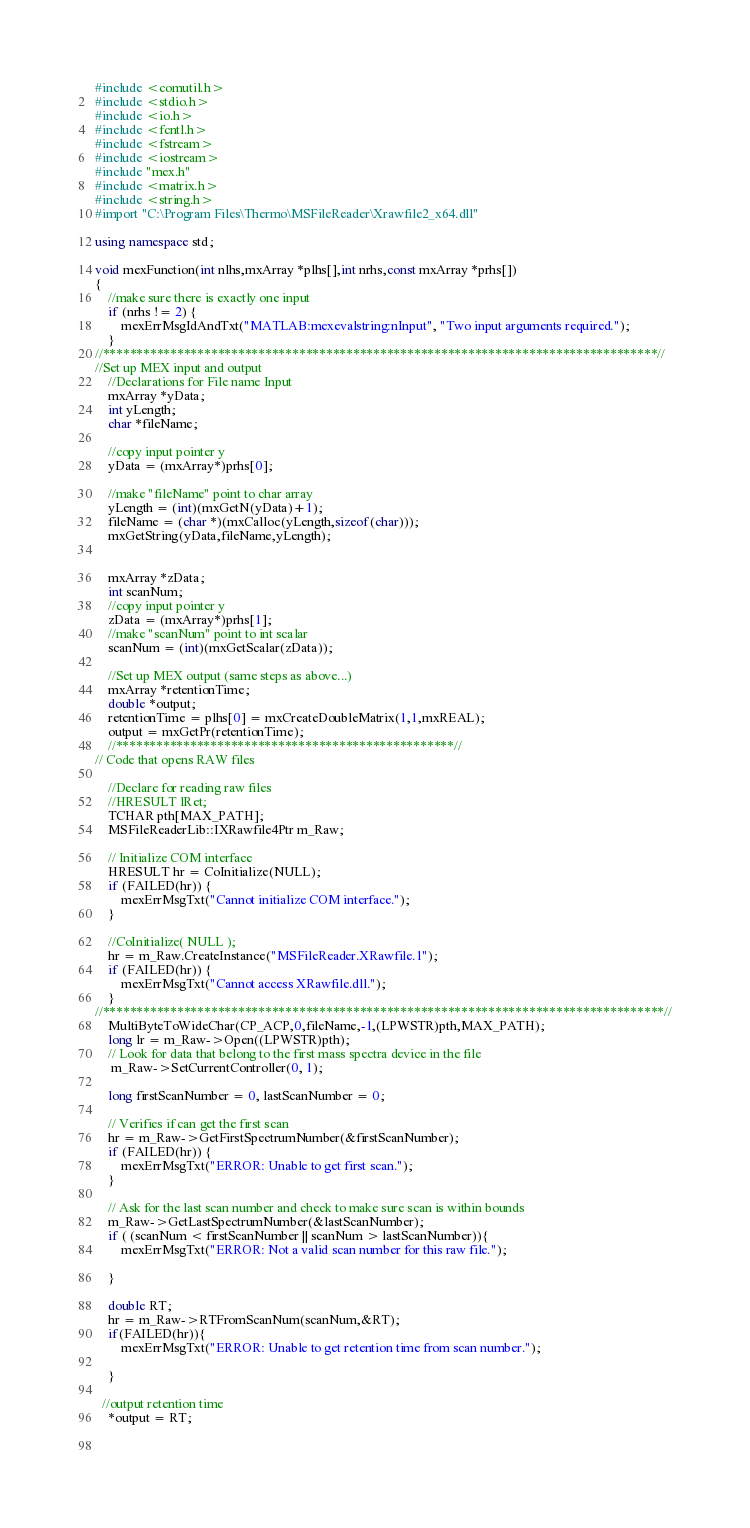<code> <loc_0><loc_0><loc_500><loc_500><_C++_>#include <comutil.h>
#include <stdio.h>
#include <io.h>
#include <fcntl.h>
#include <fstream>
#include <iostream>
#include "mex.h"
#include <matrix.h> 
#include <string.h>
#import "C:\Program Files\Thermo\MSFileReader\Xrawfile2_x64.dll"

using namespace std;

void mexFunction(int nlhs,mxArray *plhs[],int nrhs,const mxArray *prhs[])
{
    //make sure there is exactly one input
    if (nrhs != 2) {
        mexErrMsgIdAndTxt("MATLAB:mexevalstring:nInput", "Two input arguments required.");
    } 
//**********************************************************************************//
//Set up MEX input and output
    //Declarations for File name Input
    mxArray *yData;
    int yLength;
    char *fileName;
    
    //copy input pointer y
    yData = (mxArray*)prhs[0];
    
    //make "fileName" point to char array
    yLength = (int)(mxGetN(yData)+1);
    fileName = (char *)(mxCalloc(yLength,sizeof(char)));
    mxGetString(yData,fileName,yLength);

    
    mxArray *zData;
    int scanNum;
    //copy input pointer y
    zData = (mxArray*)prhs[1];
    //make "scanNum" point to int scalar
    scanNum = (int)(mxGetScalar(zData));
    
    //Set up MEX output (same steps as above...)
    mxArray *retentionTime;
    double *output;
    retentionTime = plhs[0] = mxCreateDoubleMatrix(1,1,mxREAL);
    output = mxGetPr(retentionTime);
    //**************************************************//    
// Code that opens RAW files    
    
    //Declare for reading raw files
    //HRESULT lRet;
    TCHAR pth[MAX_PATH];
    MSFileReaderLib::IXRawfile4Ptr m_Raw;
    
    // Initialize COM interface
    HRESULT hr = CoInitialize(NULL);    
    if (FAILED(hr)) {
        mexErrMsgTxt("Cannot initialize COM interface.");
    }
 
    //CoInitialize( NULL );
    hr = m_Raw.CreateInstance("MSFileReader.XRawfile.1");
    if (FAILED(hr)) {
        mexErrMsgTxt("Cannot access XRawfile.dll.");
    }
//***********************************************************************************//
    MultiByteToWideChar(CP_ACP,0,fileName,-1,(LPWSTR)pth,MAX_PATH);
    long lr = m_Raw->Open((LPWSTR)pth);
    // Look for data that belong to the first mass spectra device in the file
     m_Raw->SetCurrentController(0, 1);
    
    long firstScanNumber = 0, lastScanNumber = 0;

    // Verifies if can get the first scan
    hr = m_Raw->GetFirstSpectrumNumber(&firstScanNumber);
    if (FAILED(hr)) {
        mexErrMsgTxt("ERROR: Unable to get first scan.");
    }

    // Ask for the last scan number and check to make sure scan is within bounds
    m_Raw->GetLastSpectrumNumber(&lastScanNumber);
    if ( (scanNum < firstScanNumber || scanNum > lastScanNumber)){
        mexErrMsgTxt("ERROR: Not a valid scan number for this raw file.");
        
    }
    
    double RT;
    hr = m_Raw->RTFromScanNum(scanNum,&RT);
    if(FAILED(hr)){
        mexErrMsgTxt("ERROR: Unable to get retention time from scan number.");
        
    }
    
  //output retention time
    *output = RT; 
    
  </code> 